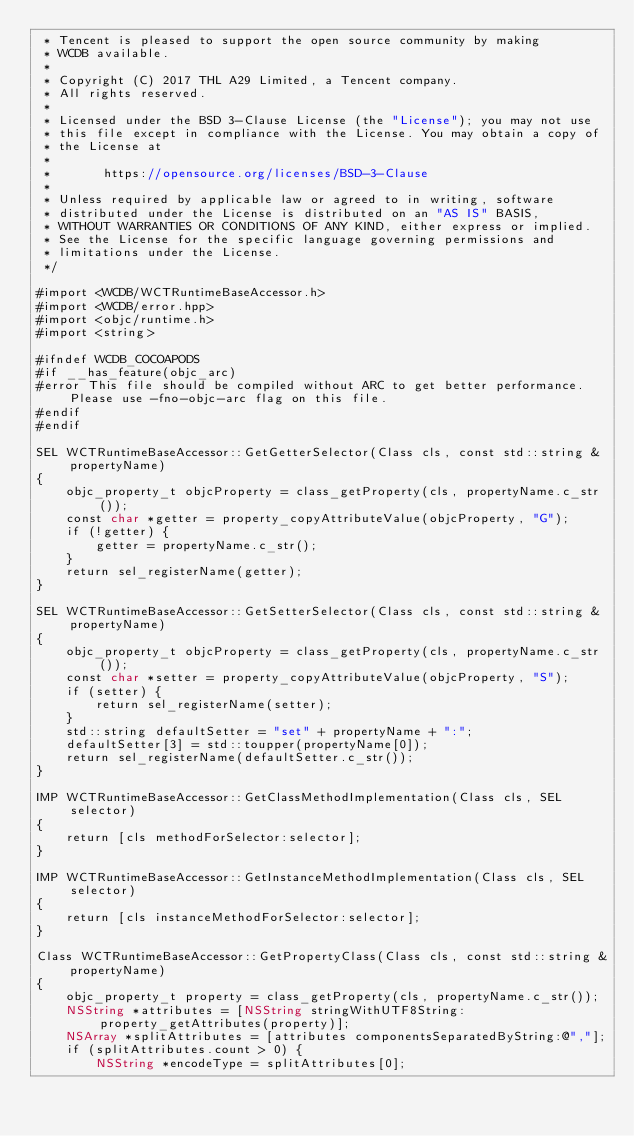<code> <loc_0><loc_0><loc_500><loc_500><_ObjectiveC_> * Tencent is pleased to support the open source community by making
 * WCDB available.
 *
 * Copyright (C) 2017 THL A29 Limited, a Tencent company.
 * All rights reserved.
 *
 * Licensed under the BSD 3-Clause License (the "License"); you may not use
 * this file except in compliance with the License. You may obtain a copy of
 * the License at
 *
 *       https://opensource.org/licenses/BSD-3-Clause
 *
 * Unless required by applicable law or agreed to in writing, software
 * distributed under the License is distributed on an "AS IS" BASIS,
 * WITHOUT WARRANTIES OR CONDITIONS OF ANY KIND, either express or implied.
 * See the License for the specific language governing permissions and
 * limitations under the License.
 */

#import <WCDB/WCTRuntimeBaseAccessor.h>
#import <WCDB/error.hpp>
#import <objc/runtime.h>
#import <string>

#ifndef WCDB_COCOAPODS
#if __has_feature(objc_arc)
#error This file should be compiled without ARC to get better performance. Please use -fno-objc-arc flag on this file.
#endif
#endif

SEL WCTRuntimeBaseAccessor::GetGetterSelector(Class cls, const std::string &propertyName)
{
    objc_property_t objcProperty = class_getProperty(cls, propertyName.c_str());
    const char *getter = property_copyAttributeValue(objcProperty, "G");
    if (!getter) {
        getter = propertyName.c_str();
    }
    return sel_registerName(getter);
}

SEL WCTRuntimeBaseAccessor::GetSetterSelector(Class cls, const std::string &propertyName)
{
    objc_property_t objcProperty = class_getProperty(cls, propertyName.c_str());
    const char *setter = property_copyAttributeValue(objcProperty, "S");
    if (setter) {
        return sel_registerName(setter);
    }
    std::string defaultSetter = "set" + propertyName + ":";
    defaultSetter[3] = std::toupper(propertyName[0]);
    return sel_registerName(defaultSetter.c_str());
}

IMP WCTRuntimeBaseAccessor::GetClassMethodImplementation(Class cls, SEL selector)
{
    return [cls methodForSelector:selector];
}

IMP WCTRuntimeBaseAccessor::GetInstanceMethodImplementation(Class cls, SEL selector)
{
    return [cls instanceMethodForSelector:selector];
}

Class WCTRuntimeBaseAccessor::GetPropertyClass(Class cls, const std::string &propertyName)
{
    objc_property_t property = class_getProperty(cls, propertyName.c_str());
    NSString *attributes = [NSString stringWithUTF8String:property_getAttributes(property)];
    NSArray *splitAttributes = [attributes componentsSeparatedByString:@","];
    if (splitAttributes.count > 0) {
        NSString *encodeType = splitAttributes[0];</code> 